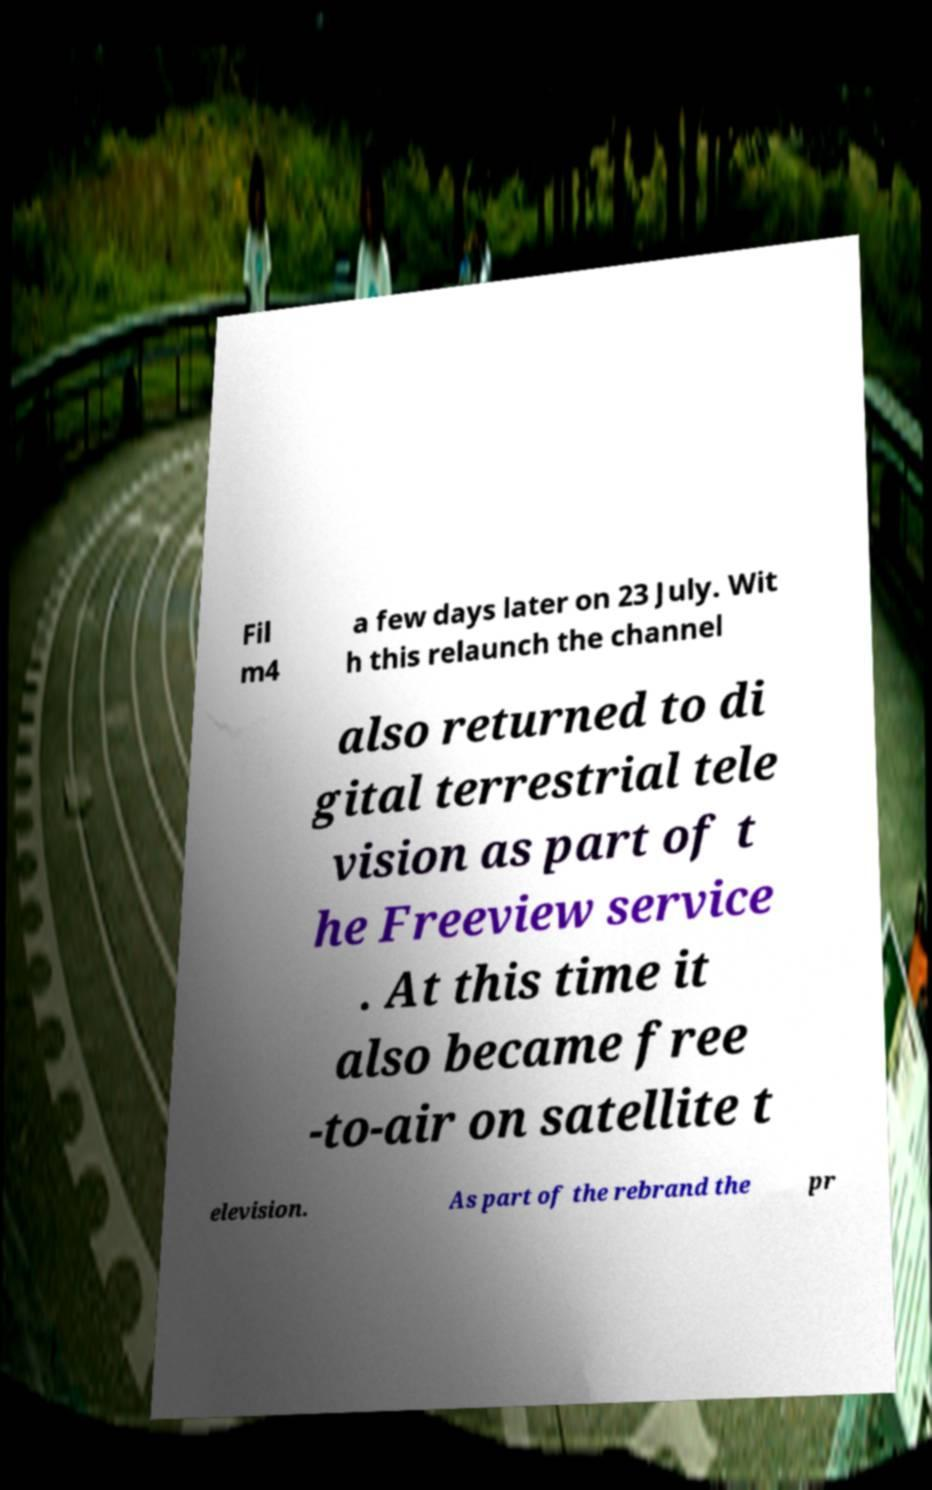Please read and relay the text visible in this image. What does it say? Fil m4 a few days later on 23 July. Wit h this relaunch the channel also returned to di gital terrestrial tele vision as part of t he Freeview service . At this time it also became free -to-air on satellite t elevision. As part of the rebrand the pr 